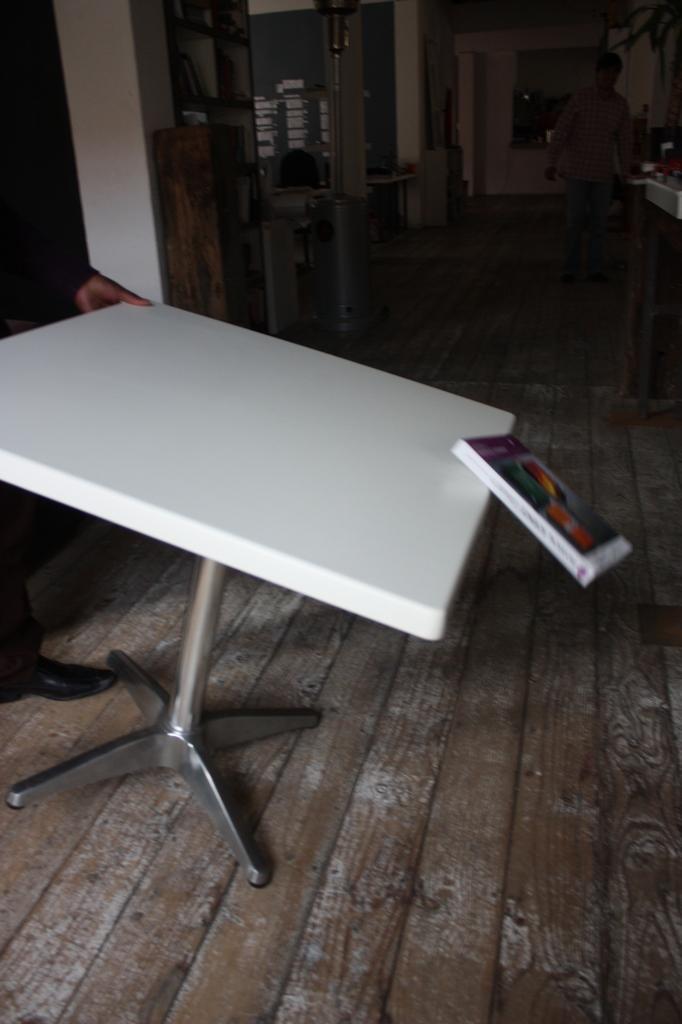How would you summarize this image in a sentence or two? This is an inside view. Here I can see a book on a table and it is falling down. On the left side there is a person standing and lifting this table. In the background there are few boxes, tables and some other objects are placed on the floor. On the right side there is another person standing. There are few pillars. 